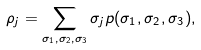<formula> <loc_0><loc_0><loc_500><loc_500>\rho _ { j } = \sum _ { \sigma _ { 1 } , \sigma _ { 2 } , \sigma _ { 3 } } \sigma _ { j } p ( \sigma _ { 1 } , \sigma _ { 2 } , \sigma _ { 3 } ) ,</formula> 